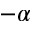Convert formula to latex. <formula><loc_0><loc_0><loc_500><loc_500>- \alpha</formula> 